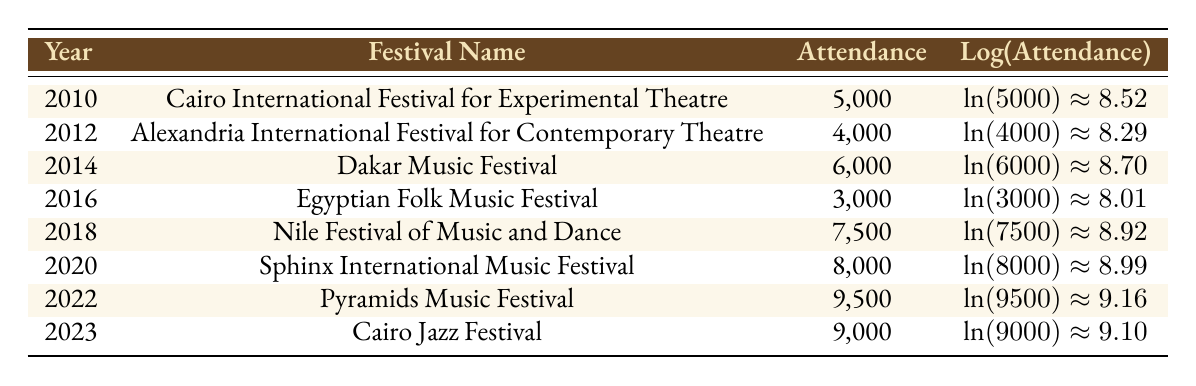What was the attendance at the Nile Festival of Music and Dance in 2018? The table lists the attendance specifically for the Nile Festival of Music and Dance in the year 2018, which is shown as 7,500.
Answer: 7,500 Which festival had the highest attendance between 2010 and 2023? By comparing the attendance values in the table, the Pyramids Music Festival in 2022 had the highest attendance of 9,500.
Answer: 9,500 What is the average attendance of the festivals listed from 2010 to 2023? First, we sum all the attendances: (5000 + 4000 + 6000 + 3000 + 7500 + 8000 + 9500 + 9000) = 43,000. Then, divide by the number of festivals (8): 43,000 / 8 = 5,375.
Answer: 5,375 Was there any festival with attendance below 4,000? Looking through the table, the attendance figures do not show any values below 4,000, so the answer is no.
Answer: No What is the difference in attendance between the Sphinx International Music Festival and the Cairo Jazz Festival? The attendance for the Sphinx International Music Festival in 2020 is 8,000 and for the Cairo Jazz Festival in 2023 is 9,000. The difference is 9,000 - 8,000 = 1,000.
Answer: 1,000 In which year did the Egyptian Folk Music Festival take place and what was its attendance? The table shows that the Egyptian Folk Music Festival took place in 2016 with an attendance of 3,000.
Answer: 2016, 3,000 How many festivals had an attendance greater than 8,000? The festivals with attendance greater than 8,000 are the Pyramids Music Festival (9,500) and Cairo Jazz Festival (9,000), so there are 2 festivals.
Answer: 2 Was the attendance for the Alexandre International Festival for Contemporary Theatre higher than that for the Egyptian Folk Music Festival? The attendance for the Alexandria International Festival in 2012 is 4,000 and for the Egyptian Folk Music Festival in 2016 is 3,000. Since 4,000 is greater than 3,000, the answer is yes.
Answer: Yes What is the logarithmic value of the attendance for the Cairo International Festival for Experimental Theatre? The attendance for this festival in 2010 is 5,000, and its logarithmic value is calculated as ln(5000) which is approximately 8.52.
Answer: Approximately 8.52 